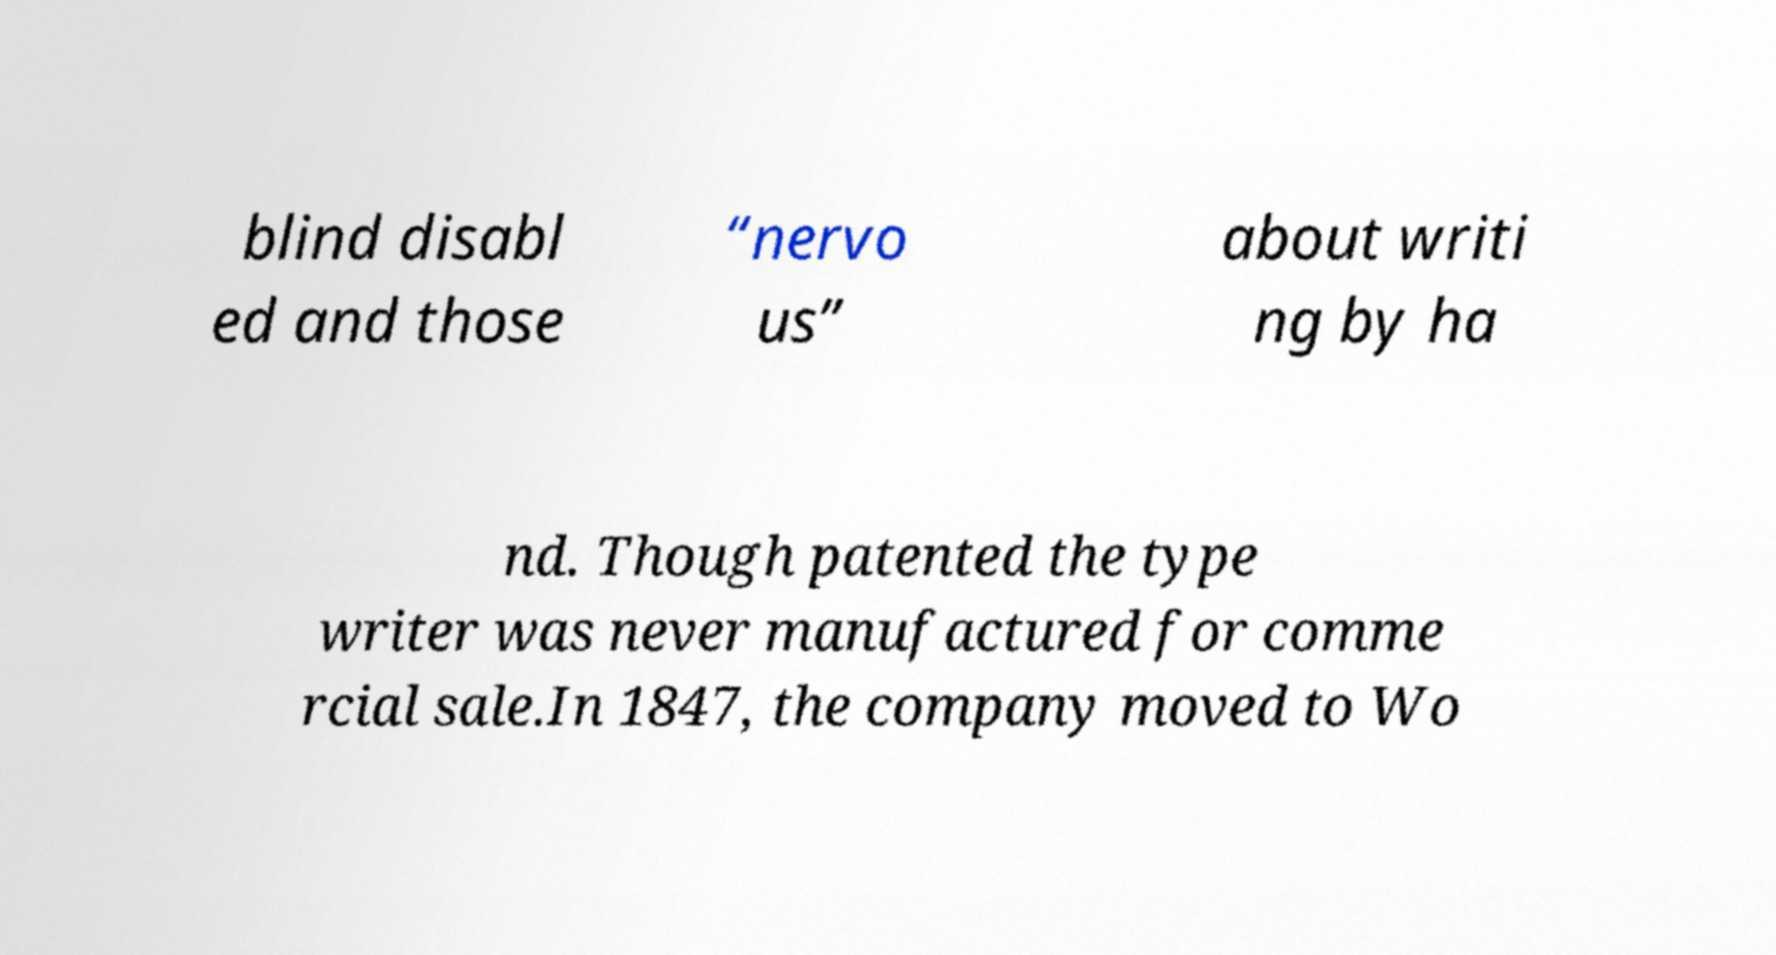Please identify and transcribe the text found in this image. blind disabl ed and those “nervo us” about writi ng by ha nd. Though patented the type writer was never manufactured for comme rcial sale.In 1847, the company moved to Wo 